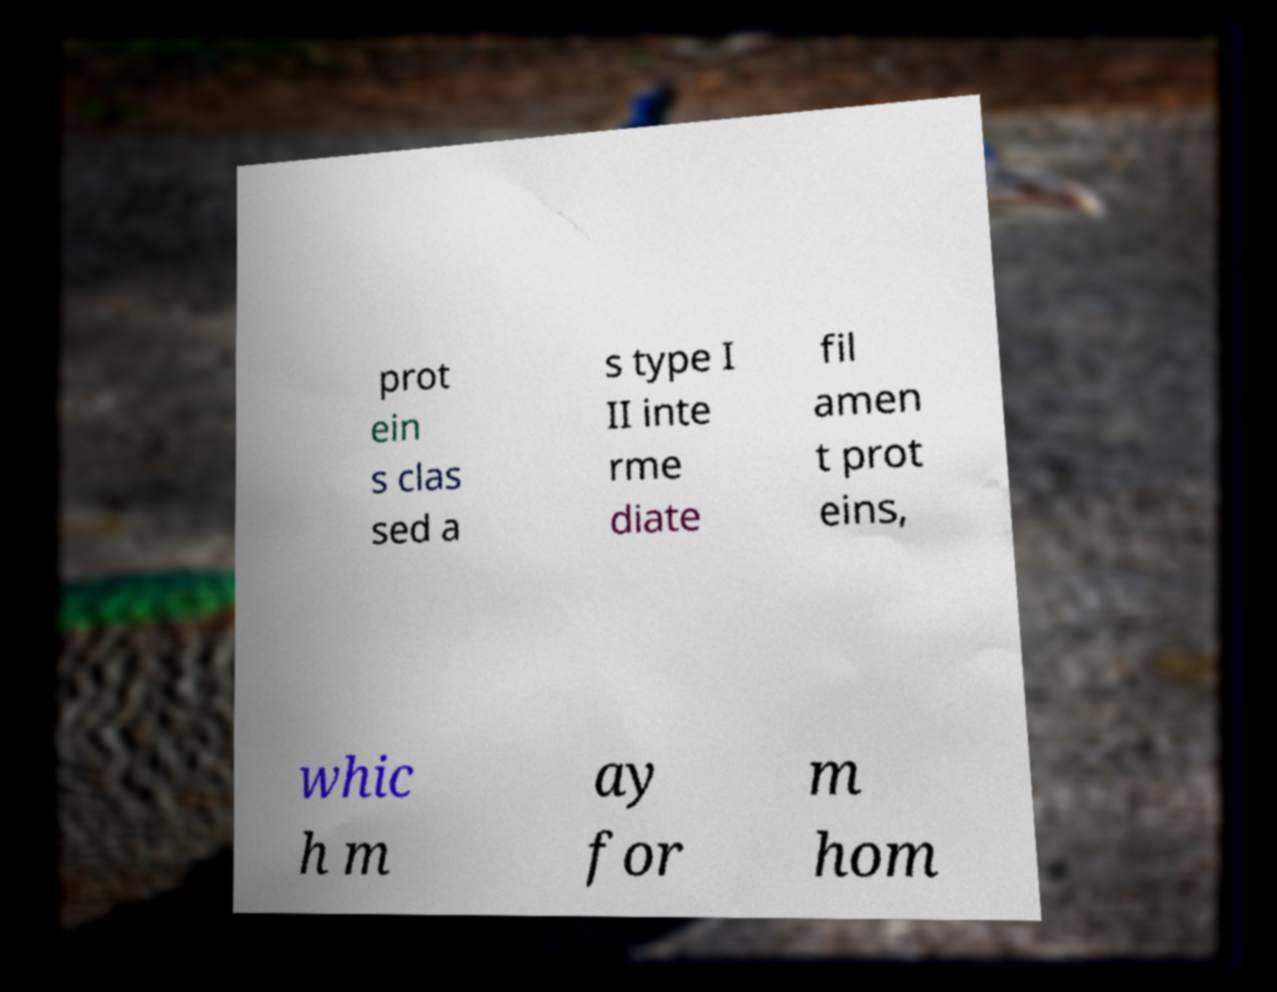Could you assist in decoding the text presented in this image and type it out clearly? prot ein s clas sed a s type I II inte rme diate fil amen t prot eins, whic h m ay for m hom 